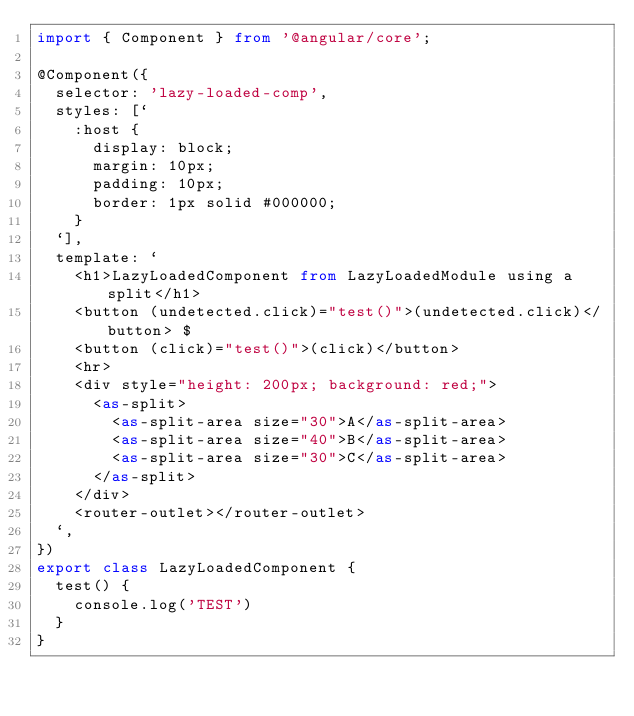Convert code to text. <code><loc_0><loc_0><loc_500><loc_500><_TypeScript_>import { Component } from '@angular/core';

@Component({
  selector: 'lazy-loaded-comp',
  styles: [`
    :host {
      display: block;
      margin: 10px;
      padding: 10px;
      border: 1px solid #000000;
    }
  `],
  template: `
    <h1>LazyLoadedComponent from LazyLoadedModule using a split</h1>
    <button (undetected.click)="test()">(undetected.click)</button> $ 
    <button (click)="test()">(click)</button>
    <hr>
    <div style="height: 200px; background: red;">
      <as-split>
        <as-split-area size="30">A</as-split-area>
        <as-split-area size="40">B</as-split-area>
        <as-split-area size="30">C</as-split-area>
      </as-split>
    </div>
    <router-outlet></router-outlet>
  `,
})
export class LazyLoadedComponent {
  test() {
    console.log('TEST')
  }
}
</code> 